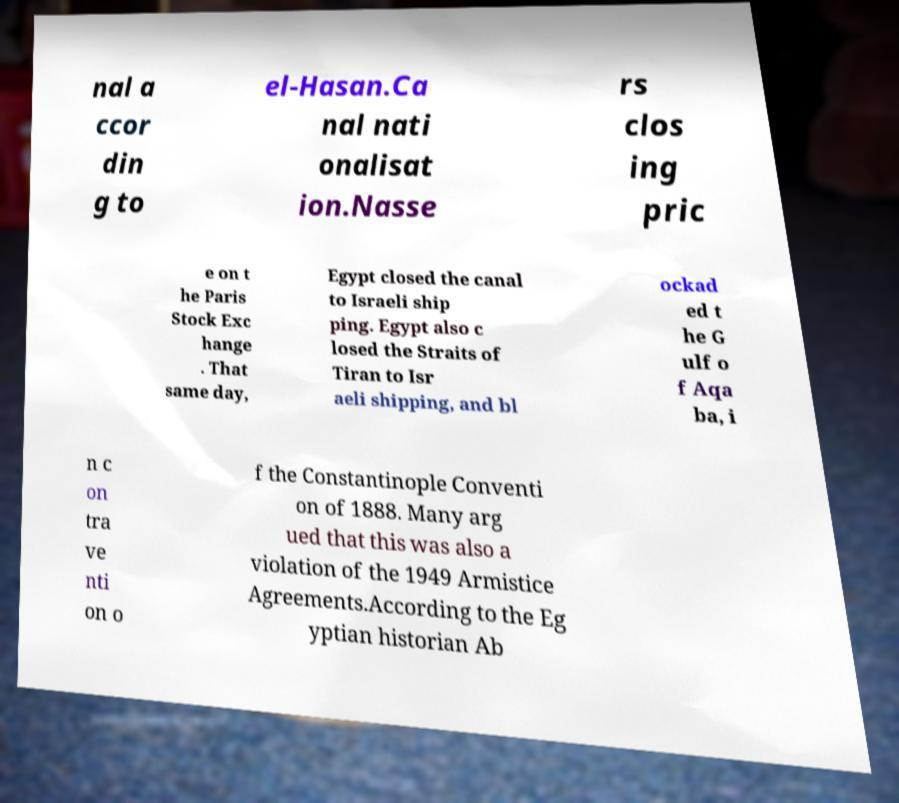Could you assist in decoding the text presented in this image and type it out clearly? nal a ccor din g to el-Hasan.Ca nal nati onalisat ion.Nasse rs clos ing pric e on t he Paris Stock Exc hange . That same day, Egypt closed the canal to Israeli ship ping. Egypt also c losed the Straits of Tiran to Isr aeli shipping, and bl ockad ed t he G ulf o f Aqa ba, i n c on tra ve nti on o f the Constantinople Conventi on of 1888. Many arg ued that this was also a violation of the 1949 Armistice Agreements.According to the Eg yptian historian Ab 